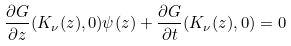Convert formula to latex. <formula><loc_0><loc_0><loc_500><loc_500>\frac { \partial G } { \partial z } ( K _ { \nu } ( z ) , 0 ) \psi ( z ) + \frac { \partial G } { \partial t } ( K _ { \nu } ( z ) , 0 ) = 0</formula> 